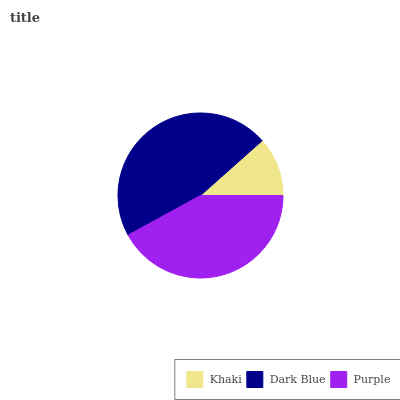Is Khaki the minimum?
Answer yes or no. Yes. Is Dark Blue the maximum?
Answer yes or no. Yes. Is Purple the minimum?
Answer yes or no. No. Is Purple the maximum?
Answer yes or no. No. Is Dark Blue greater than Purple?
Answer yes or no. Yes. Is Purple less than Dark Blue?
Answer yes or no. Yes. Is Purple greater than Dark Blue?
Answer yes or no. No. Is Dark Blue less than Purple?
Answer yes or no. No. Is Purple the high median?
Answer yes or no. Yes. Is Purple the low median?
Answer yes or no. Yes. Is Dark Blue the high median?
Answer yes or no. No. Is Khaki the low median?
Answer yes or no. No. 